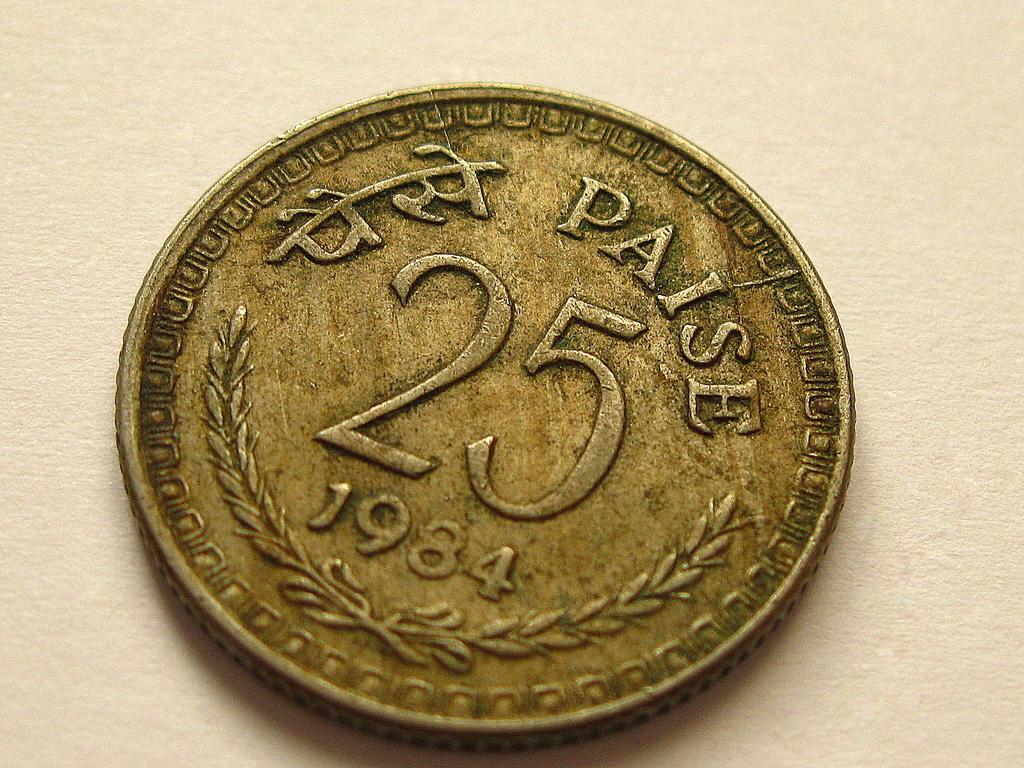What year was the coin produced?
Your answer should be very brief. 1984. The denomination of the coin is?
Your answer should be compact. 25. 